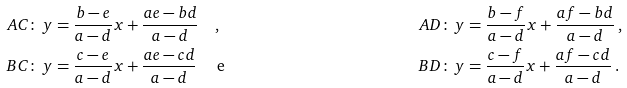<formula> <loc_0><loc_0><loc_500><loc_500>A C \colon & \, y = \frac { b - e } { a - d } x + \frac { a e - b d } { a - d } \quad , & A D \colon & \, y = \frac { b - f } { a - d } x + \frac { a f - b d } { a - d } \, , \\ B C \colon & \, y = \frac { c - e } { a - d } x + \frac { a e - c d } { a - d } \quad \text { e} & B D \colon & \, y = \frac { c - f } { a - d } x + \frac { a f - c d } { a - d } \, .</formula> 